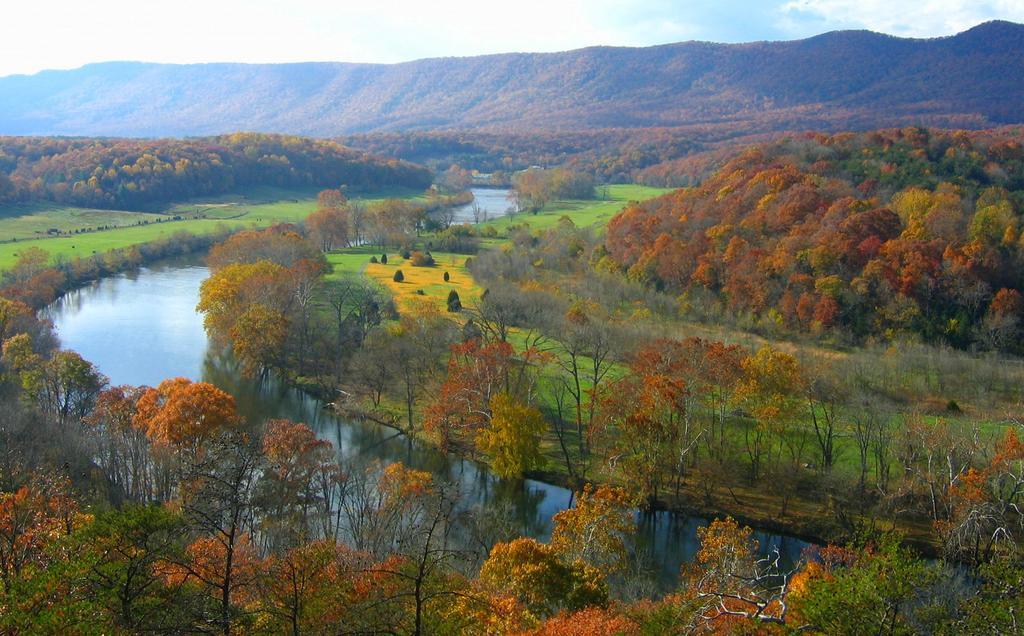In one or two sentences, can you explain what this image depicts? In the picture we can see a Ariel view of the scenery with grass surfaces, plants, trees and water ways and in the background we can see many trees, hills and sky. 